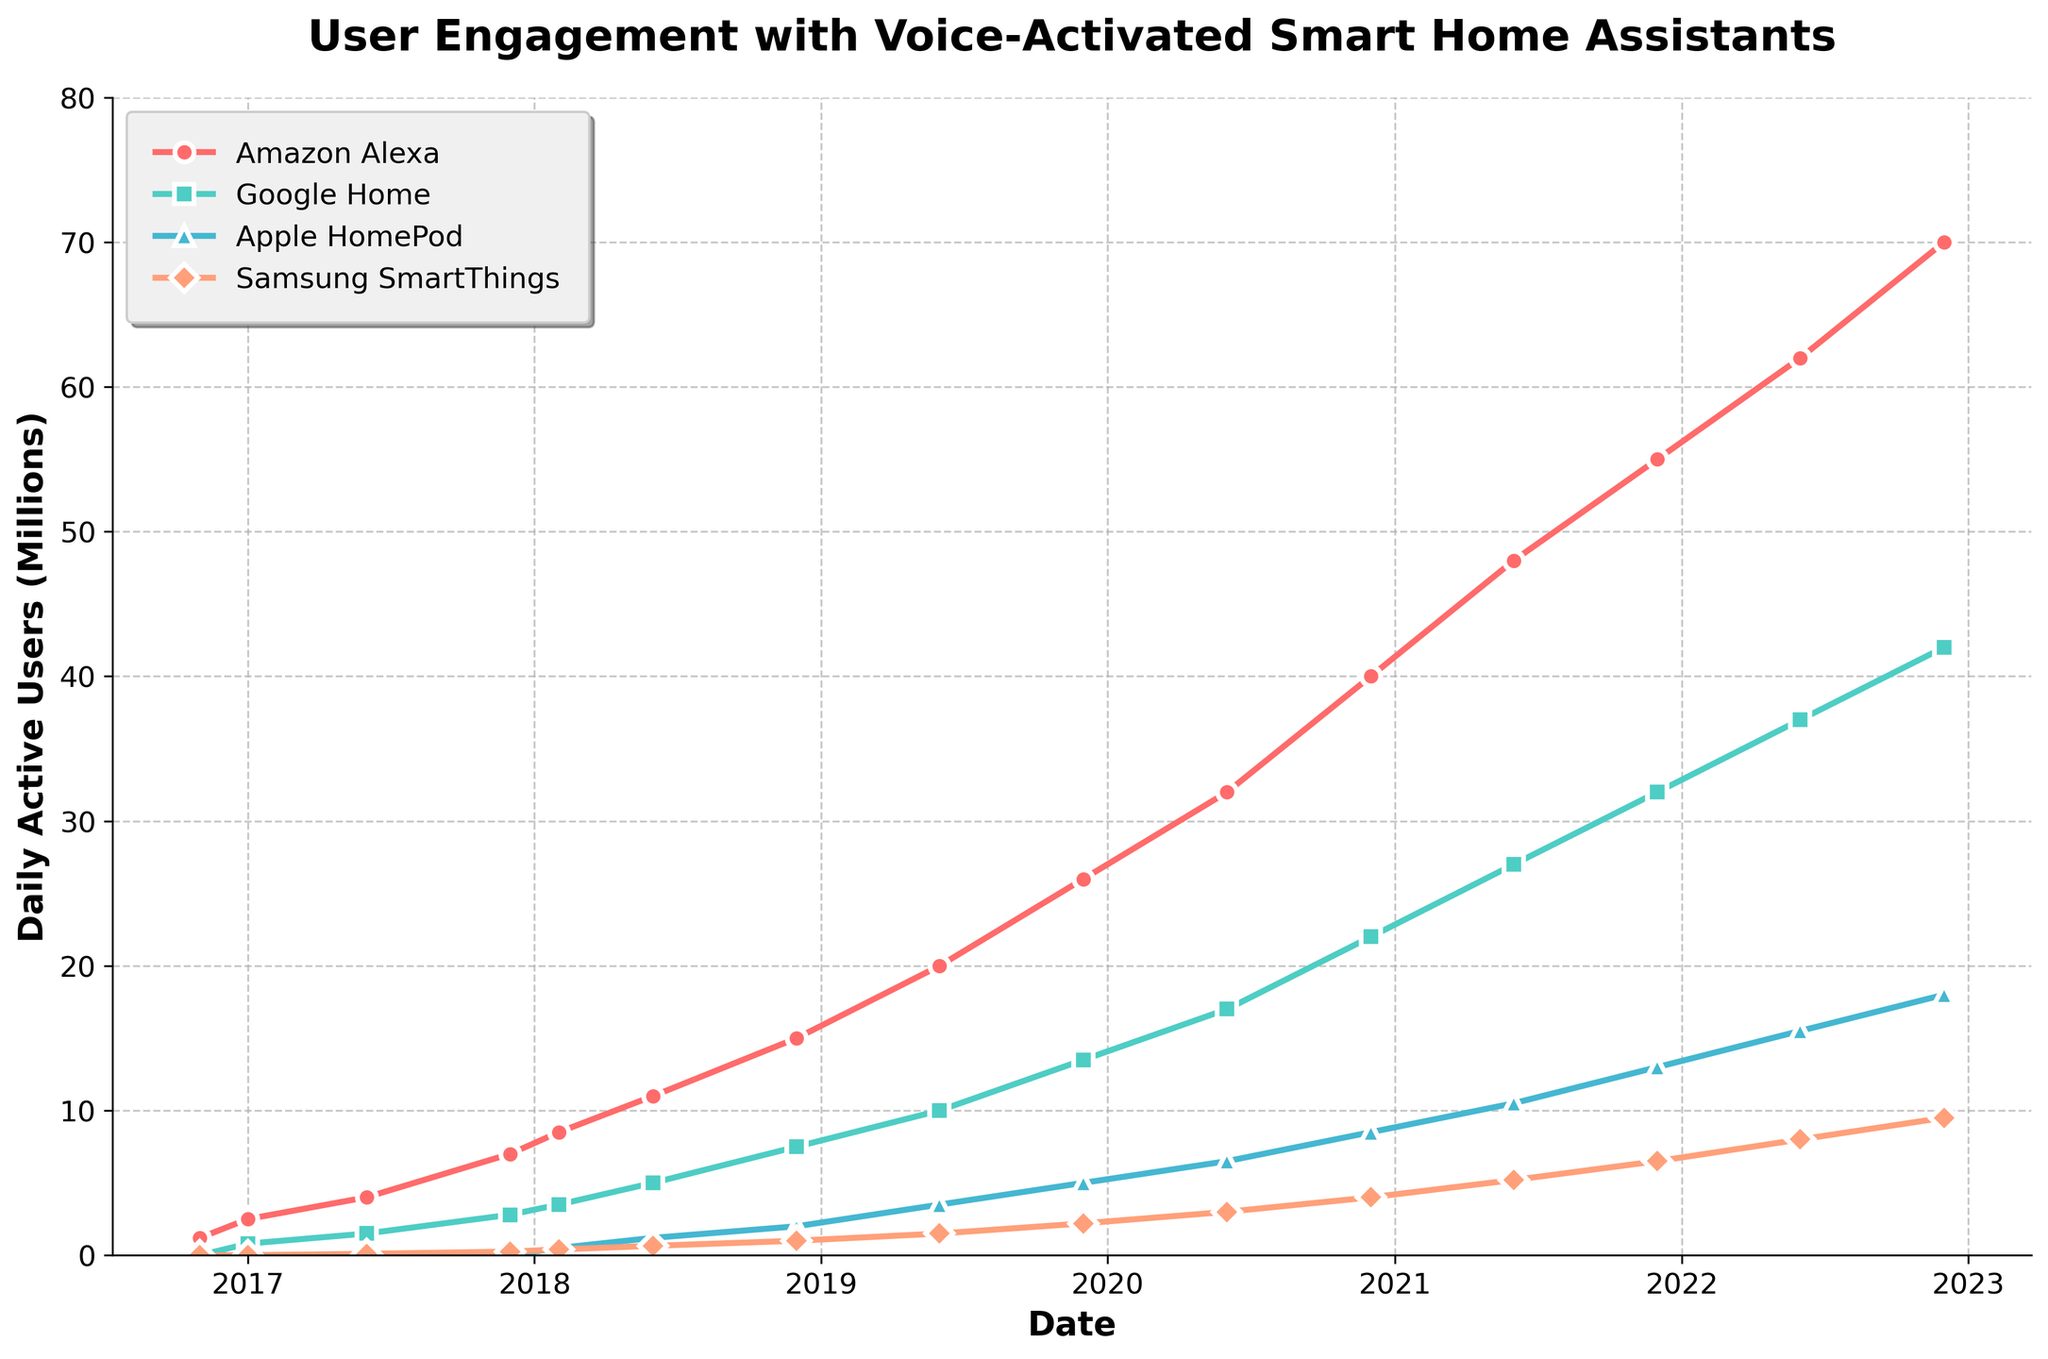What is the trend for daily active users of Amazon Alexa over the time period shown? By looking at the chart, the number of daily active users for Amazon Alexa continuously increases from November 2016 to December 2022. This can be deduced from the line that steadily rises over time, indicating constant growth.
Answer: Continuous increase Which platform reached 10 million daily active users first, Google Home or Apple HomePod? According to the chart, Google Home reached 10 million daily active users around June 2019, and Apple HomePod reached the same milestone after June 2020. This is observed from the dates corresponding to the points on each line that meet the 10 million mark on the y-axis.
Answer: Google Home How did the daily active users of Samsung SmartThings compare to Google Home in December 2022? In December 2022, Samsung SmartThings had around 9.5 million daily active users, while Google Home had around 42 million. This comparison can be directly made from where each line intersects the date 2022-12-01 on the x-axis.
Answer: Google Home had more users What is the approximate average number of daily active users for Apple HomePod from its launch until December 2022? Apple HomePod's daily active users start from about 500,000 in February 2018 and increase to around 18 million by December 2022. The average number can be approximated by (0.5 + 12 + 2 + 3.5 + 5 + 6.5 + 8.5 + 10.5 + 13 + 15.5 + 18)/11 ≈ 9.27 million users.
Answer: ~9.27 million users By how many millions did Amazon Alexa’s daily active users grow between December 2017 and December 2018? The number of daily active users for Amazon Alexa was 7 million in December 2017 and 15 million in December 2018. The difference can be calculated as 15 million - 7 million = 8 million.
Answer: 8 million Which platform experienced the sharpest increase in daily active users between June 2020 and June 2021? By examining the slopes of the lines, Amazon Alexa's line shows the steepest increase between these dates, signifying the sharpest rise in active users among the platforms in that period.
Answer: Amazon Alexa What is the total number of daily active users across all platforms in June 2019? Summing the values for June 2019: Amazon Alexa (20M), Google Home (10M), Apple HomePod (3.5M), and Samsung SmartThings (1.5M), gives a total of 20 + 10 + 3.5 + 1.5 = 35 million users.
Answer: 35 million users 